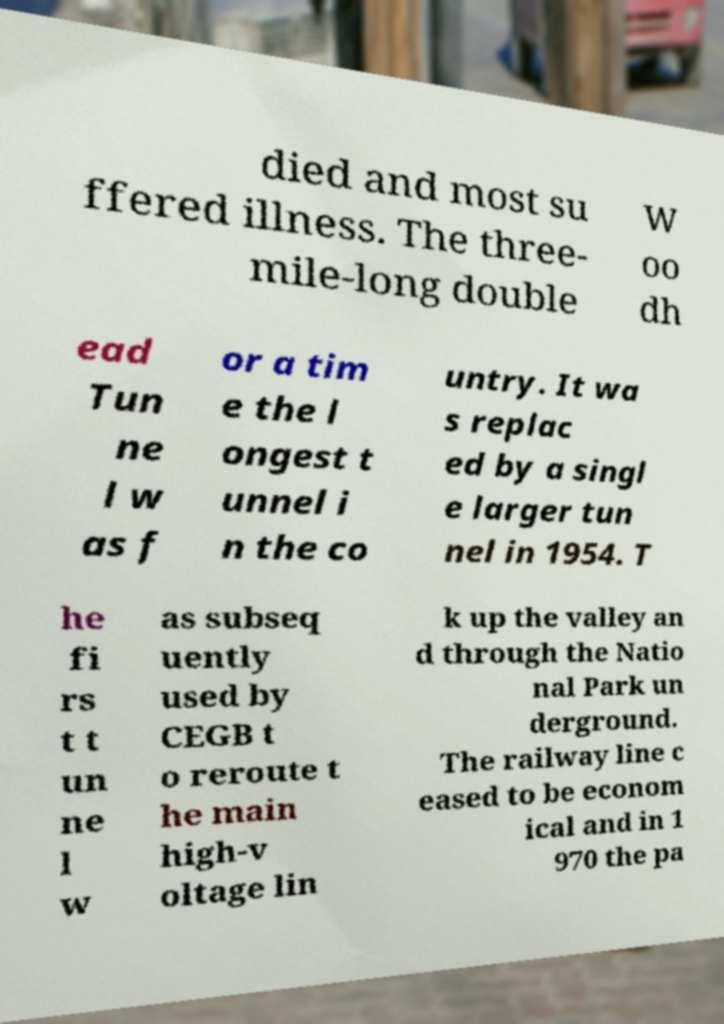Can you read and provide the text displayed in the image?This photo seems to have some interesting text. Can you extract and type it out for me? died and most su ffered illness. The three- mile-long double W oo dh ead Tun ne l w as f or a tim e the l ongest t unnel i n the co untry. It wa s replac ed by a singl e larger tun nel in 1954. T he fi rs t t un ne l w as subseq uently used by CEGB t o reroute t he main high-v oltage lin k up the valley an d through the Natio nal Park un derground. The railway line c eased to be econom ical and in 1 970 the pa 